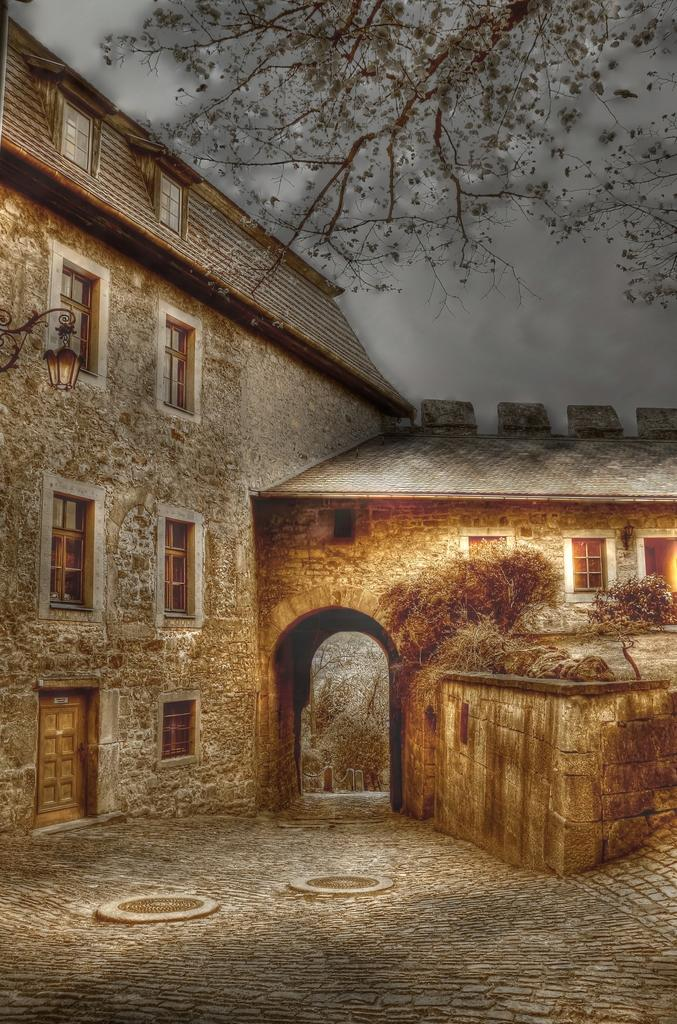What type of artwork is depicted in the image? The image appears to be a painting. What structure can be seen in the painting? There is a building in the image. What type of natural elements are present in the painting? There are trees and plants in the image. Can you describe any lighting features in the painting? There is a light on the wall of the building. What type of quiver is hanging on the wall of the building in the painting? There is no quiver present in the painting; it features a light on the wall of the building. What game is being played in the painting? There is no game being played in the painting; it is a depiction of a building, trees, plants, and a light on the wall. 